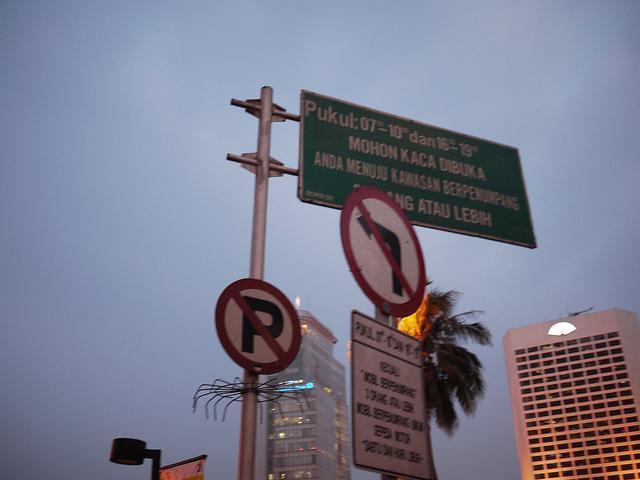How many arrow signs?
Give a very brief answer. 1. 